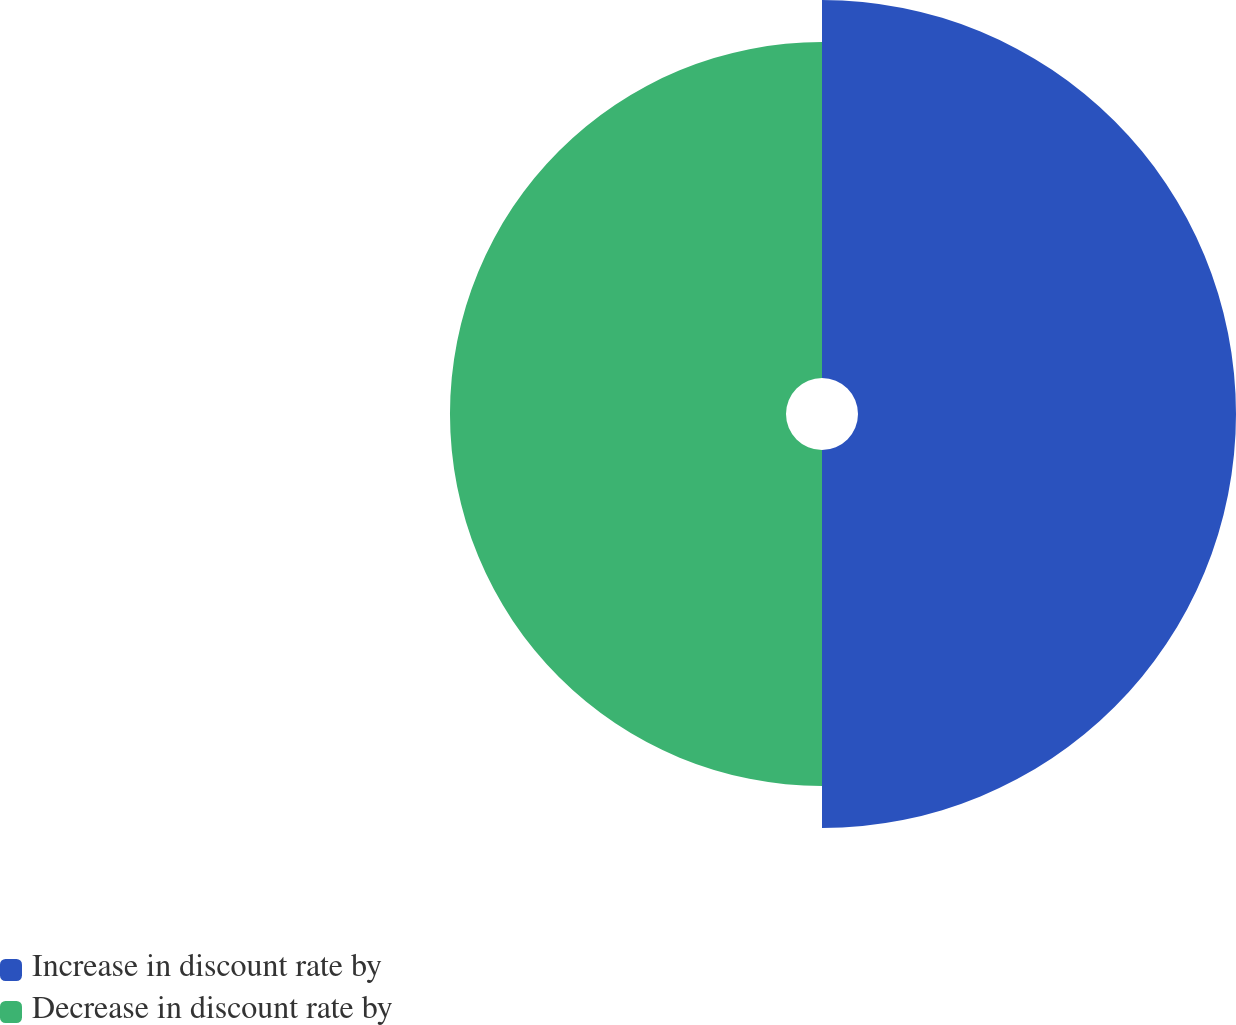Convert chart. <chart><loc_0><loc_0><loc_500><loc_500><pie_chart><fcel>Increase in discount rate by<fcel>Decrease in discount rate by<nl><fcel>52.94%<fcel>47.06%<nl></chart> 